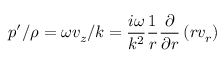Convert formula to latex. <formula><loc_0><loc_0><loc_500><loc_500>p ^ { \prime } / \rho = \omega v _ { z } / k = \frac { i \omega } { k ^ { 2 } } \frac { 1 } { r } \frac { \partial } { \partial r } \left ( r v _ { r } \right )</formula> 